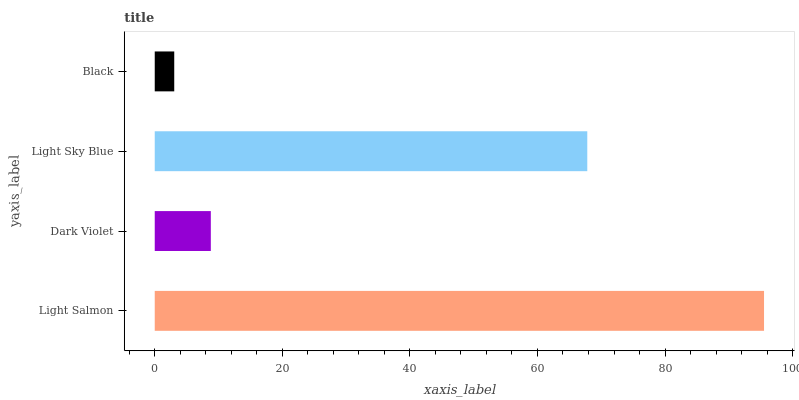Is Black the minimum?
Answer yes or no. Yes. Is Light Salmon the maximum?
Answer yes or no. Yes. Is Dark Violet the minimum?
Answer yes or no. No. Is Dark Violet the maximum?
Answer yes or no. No. Is Light Salmon greater than Dark Violet?
Answer yes or no. Yes. Is Dark Violet less than Light Salmon?
Answer yes or no. Yes. Is Dark Violet greater than Light Salmon?
Answer yes or no. No. Is Light Salmon less than Dark Violet?
Answer yes or no. No. Is Light Sky Blue the high median?
Answer yes or no. Yes. Is Dark Violet the low median?
Answer yes or no. Yes. Is Dark Violet the high median?
Answer yes or no. No. Is Light Salmon the low median?
Answer yes or no. No. 